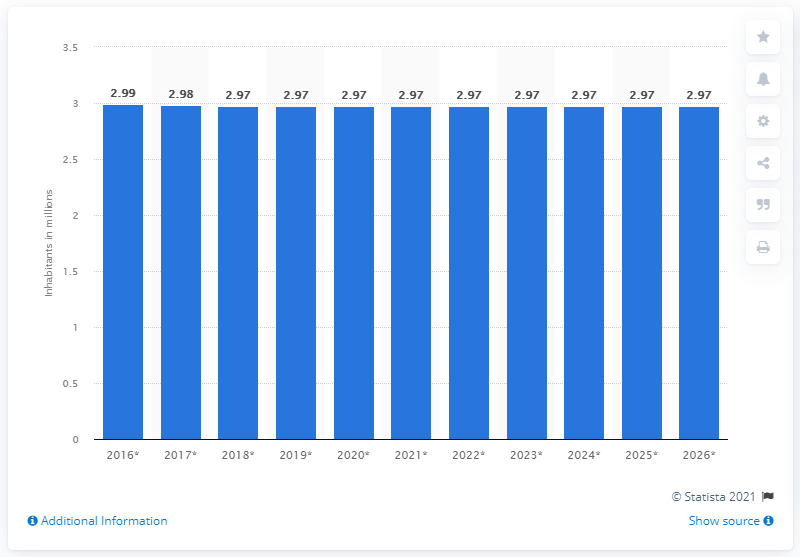Identify some key points in this picture. In 2020, the population of Armenia was 2.97 million. 